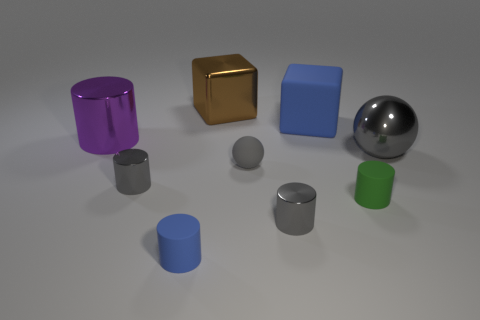How is lighting used in this image? The lighting in the image appears to be set up to create a soft shadow effect, giving the objects depth and definition. The light source seems to be coming from the top, as indicated by the shadows directly beneath and slightly to the side of the objects. The softness of the shadows suggests a diffused lighting, often used to emphasize the form of objects without creating harsh contrasts. 